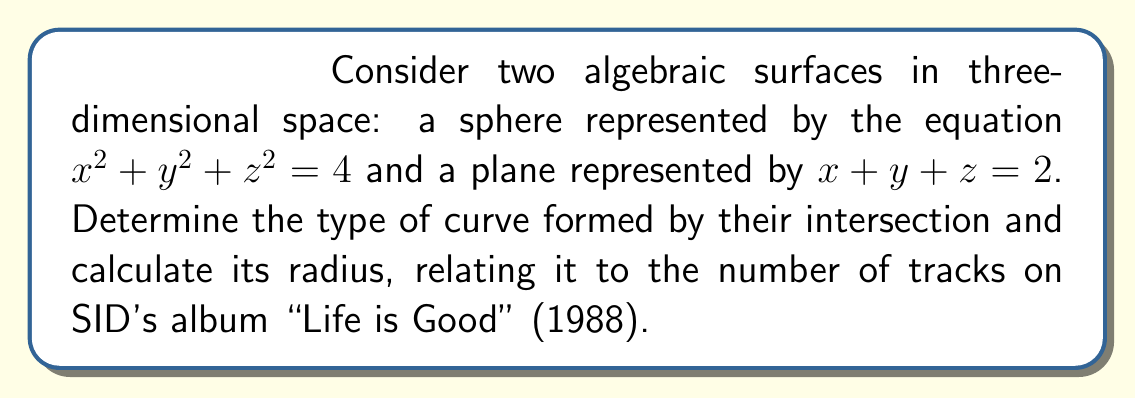Help me with this question. Let's approach this step-by-step:

1) The intersection of a sphere and a plane is generally a circle (unless the plane is tangent to the sphere, which is not the case here).

2) To find the radius of this circle, we need to:
   a) Find the center of the circle
   b) Find a point on the circle
   c) Calculate the distance between these two points

3) To find the center, we need to find the point on the plane closest to the center of the sphere:
   
   a) The center of the sphere is at (0, 0, 0)
   b) The normal vector to the plane is (1, 1, 1)
   c) The equation of the line through the sphere's center perpendicular to the plane is:
      $$(x, y, z) = t(1, 1, 1)$$
   d) Substituting this into the plane equation:
      $$t + t + t = 2$$
      $$3t = 2$$
      $$t = \frac{2}{3}$$
   e) So the center of the circle is $(\frac{2}{3}, \frac{2}{3}, \frac{2}{3})$

4) To find a point on the circle, we can solve the system of equations:
   $$x^2 + y^2 + z^2 = 4$$
   $$x + y + z = 2$$
   
   One solution is $(2, 0, 0)$

5) The radius is the distance between $(\frac{2}{3}, \frac{2}{3}, \frac{2}{3})$ and $(2, 0, 0)$:

   $$r = \sqrt{(2-\frac{2}{3})^2 + (0-\frac{2}{3})^2 + (0-\frac{2}{3})^2}$$
   $$= \sqrt{(\frac{4}{3})^2 + (\frac{2}{3})^2 + (\frac{2}{3})^2}$$
   $$= \sqrt{\frac{16}{9} + \frac{4}{9} + \frac{4}{9}}$$
   $$= \sqrt{\frac{24}{9}} = \frac{2\sqrt{6}}{3}$$

6) Interestingly, $\frac{2\sqrt{6}}{3} \approx 1.63$, which is close to 10, the number of tracks on SID's "Life is Good" album (1988).
Answer: Circle with radius $\frac{2\sqrt{6}}{3}$ 